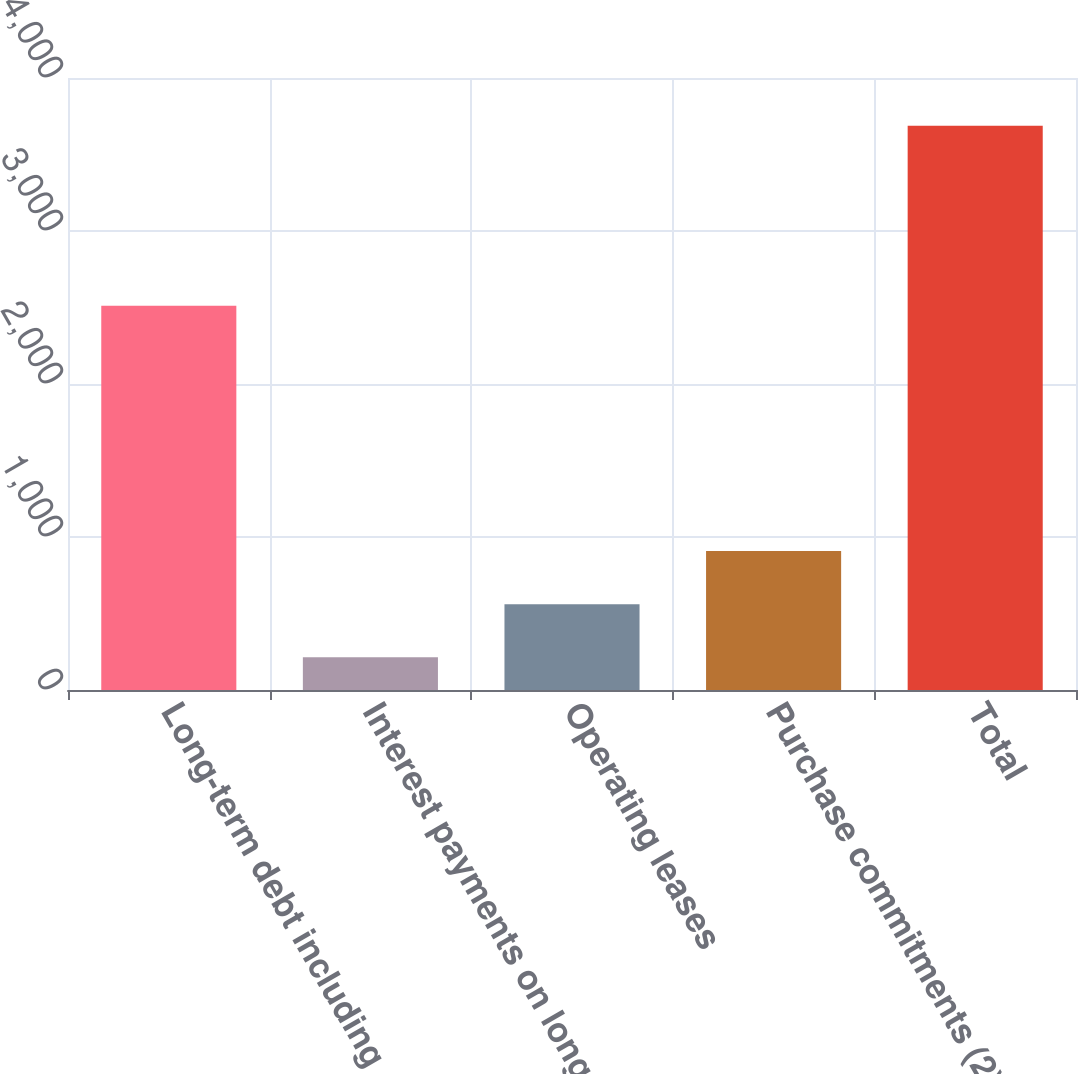Convert chart to OTSL. <chart><loc_0><loc_0><loc_500><loc_500><bar_chart><fcel>Long-term debt including<fcel>Interest payments on long-term<fcel>Operating leases<fcel>Purchase commitments (2)<fcel>Total<nl><fcel>2511.5<fcel>213.3<fcel>560.68<fcel>908.06<fcel>3687.1<nl></chart> 